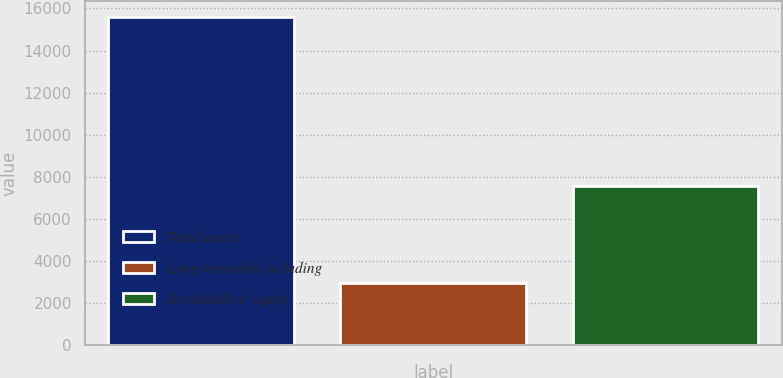Convert chart. <chart><loc_0><loc_0><loc_500><loc_500><bar_chart><fcel>Total assets<fcel>Long-term debt including<fcel>Stockholders' equity<nl><fcel>15598<fcel>2938<fcel>7548<nl></chart> 